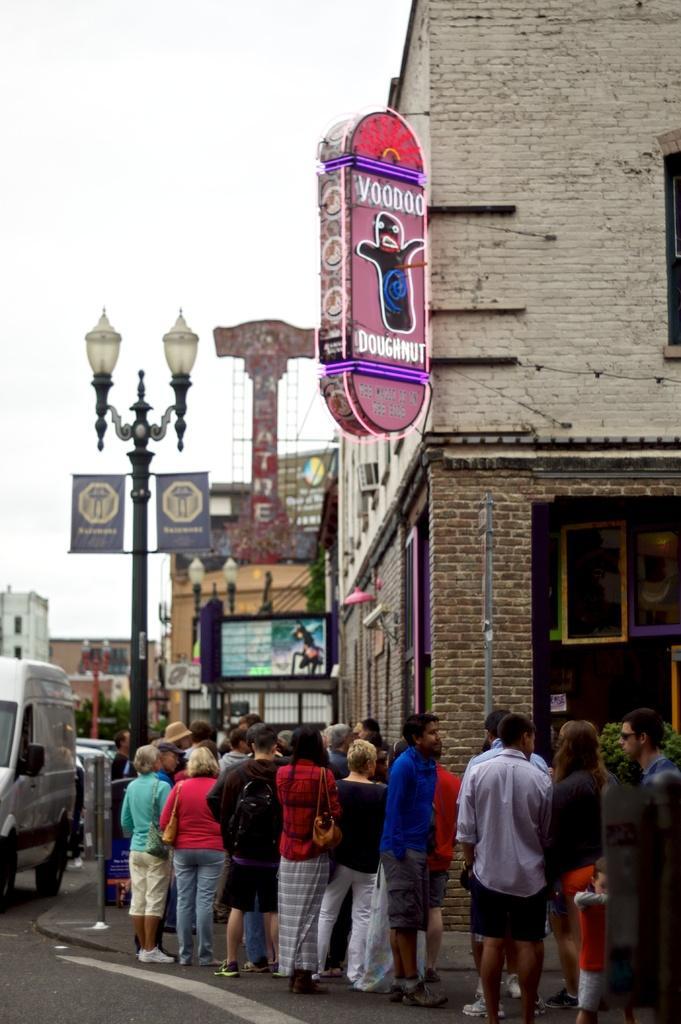Can you describe this image briefly? In this image we can see few people standing in front of the road and a few vehicles on the road there are light poles, boards attached to the building and sky in the background. 